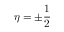<formula> <loc_0><loc_0><loc_500><loc_500>\eta = \pm \frac { 1 } { 2 }</formula> 